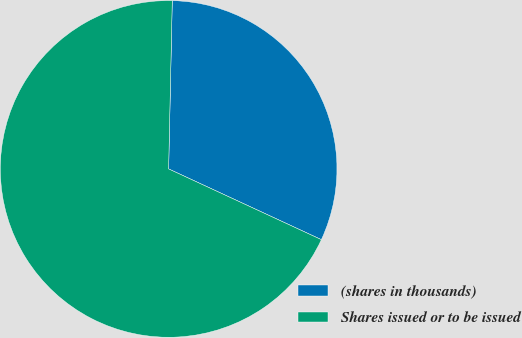<chart> <loc_0><loc_0><loc_500><loc_500><pie_chart><fcel>(shares in thousands)<fcel>Shares issued or to be issued<nl><fcel>31.56%<fcel>68.44%<nl></chart> 